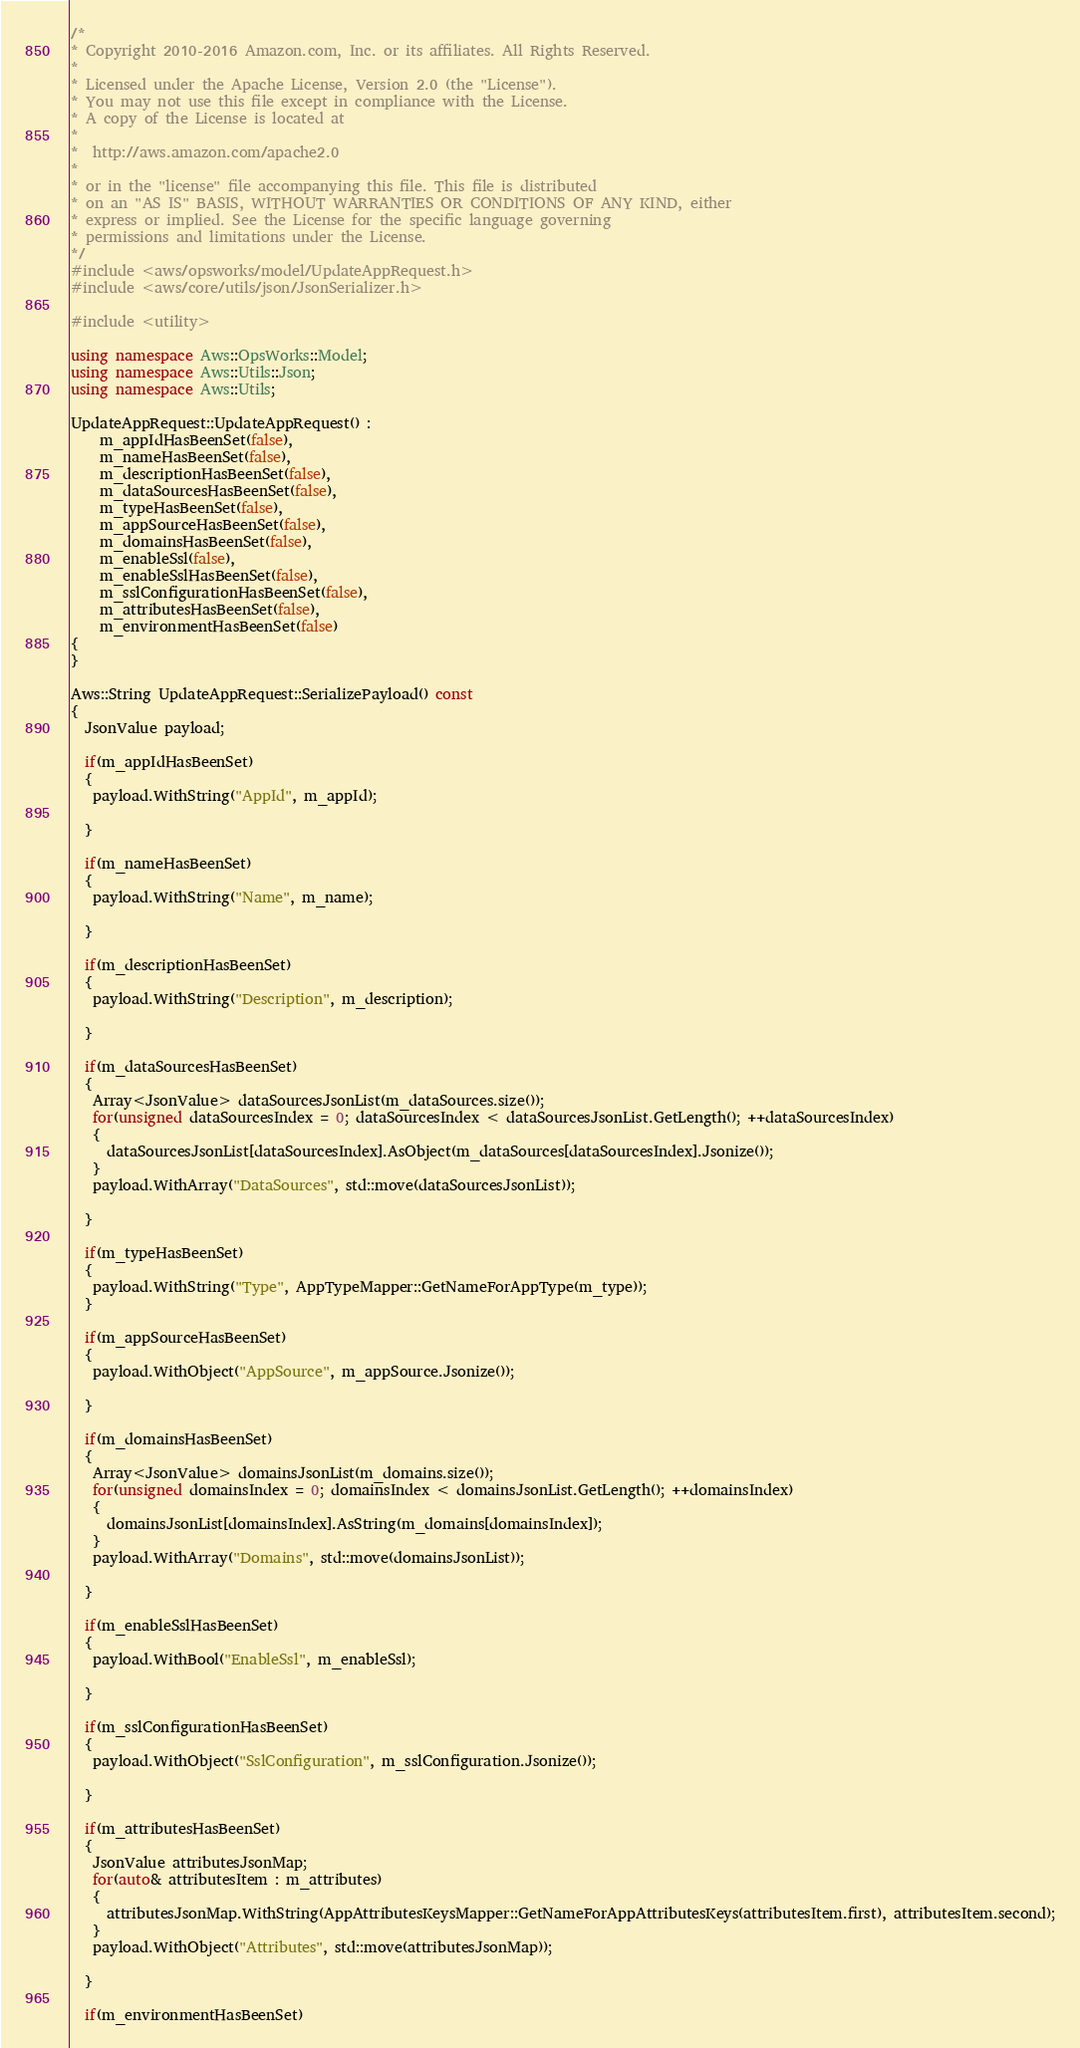Convert code to text. <code><loc_0><loc_0><loc_500><loc_500><_C++_>/*
* Copyright 2010-2016 Amazon.com, Inc. or its affiliates. All Rights Reserved.
*
* Licensed under the Apache License, Version 2.0 (the "License").
* You may not use this file except in compliance with the License.
* A copy of the License is located at
*
*  http://aws.amazon.com/apache2.0
*
* or in the "license" file accompanying this file. This file is distributed
* on an "AS IS" BASIS, WITHOUT WARRANTIES OR CONDITIONS OF ANY KIND, either
* express or implied. See the License for the specific language governing
* permissions and limitations under the License.
*/
#include <aws/opsworks/model/UpdateAppRequest.h>
#include <aws/core/utils/json/JsonSerializer.h>

#include <utility>

using namespace Aws::OpsWorks::Model;
using namespace Aws::Utils::Json;
using namespace Aws::Utils;

UpdateAppRequest::UpdateAppRequest() : 
    m_appIdHasBeenSet(false),
    m_nameHasBeenSet(false),
    m_descriptionHasBeenSet(false),
    m_dataSourcesHasBeenSet(false),
    m_typeHasBeenSet(false),
    m_appSourceHasBeenSet(false),
    m_domainsHasBeenSet(false),
    m_enableSsl(false),
    m_enableSslHasBeenSet(false),
    m_sslConfigurationHasBeenSet(false),
    m_attributesHasBeenSet(false),
    m_environmentHasBeenSet(false)
{
}

Aws::String UpdateAppRequest::SerializePayload() const
{
  JsonValue payload;

  if(m_appIdHasBeenSet)
  {
   payload.WithString("AppId", m_appId);

  }

  if(m_nameHasBeenSet)
  {
   payload.WithString("Name", m_name);

  }

  if(m_descriptionHasBeenSet)
  {
   payload.WithString("Description", m_description);

  }

  if(m_dataSourcesHasBeenSet)
  {
   Array<JsonValue> dataSourcesJsonList(m_dataSources.size());
   for(unsigned dataSourcesIndex = 0; dataSourcesIndex < dataSourcesJsonList.GetLength(); ++dataSourcesIndex)
   {
     dataSourcesJsonList[dataSourcesIndex].AsObject(m_dataSources[dataSourcesIndex].Jsonize());
   }
   payload.WithArray("DataSources", std::move(dataSourcesJsonList));

  }

  if(m_typeHasBeenSet)
  {
   payload.WithString("Type", AppTypeMapper::GetNameForAppType(m_type));
  }

  if(m_appSourceHasBeenSet)
  {
   payload.WithObject("AppSource", m_appSource.Jsonize());

  }

  if(m_domainsHasBeenSet)
  {
   Array<JsonValue> domainsJsonList(m_domains.size());
   for(unsigned domainsIndex = 0; domainsIndex < domainsJsonList.GetLength(); ++domainsIndex)
   {
     domainsJsonList[domainsIndex].AsString(m_domains[domainsIndex]);
   }
   payload.WithArray("Domains", std::move(domainsJsonList));

  }

  if(m_enableSslHasBeenSet)
  {
   payload.WithBool("EnableSsl", m_enableSsl);

  }

  if(m_sslConfigurationHasBeenSet)
  {
   payload.WithObject("SslConfiguration", m_sslConfiguration.Jsonize());

  }

  if(m_attributesHasBeenSet)
  {
   JsonValue attributesJsonMap;
   for(auto& attributesItem : m_attributes)
   {
     attributesJsonMap.WithString(AppAttributesKeysMapper::GetNameForAppAttributesKeys(attributesItem.first), attributesItem.second);
   }
   payload.WithObject("Attributes", std::move(attributesJsonMap));

  }

  if(m_environmentHasBeenSet)</code> 